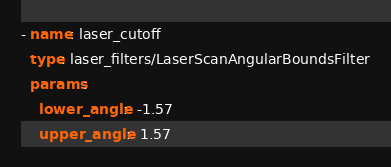<code> <loc_0><loc_0><loc_500><loc_500><_YAML_>- name: laser_cutoff
  type: laser_filters/LaserScanAngularBoundsFilter
  params:
    lower_angle:  -1.57
    upper_angle:  1.57
</code> 